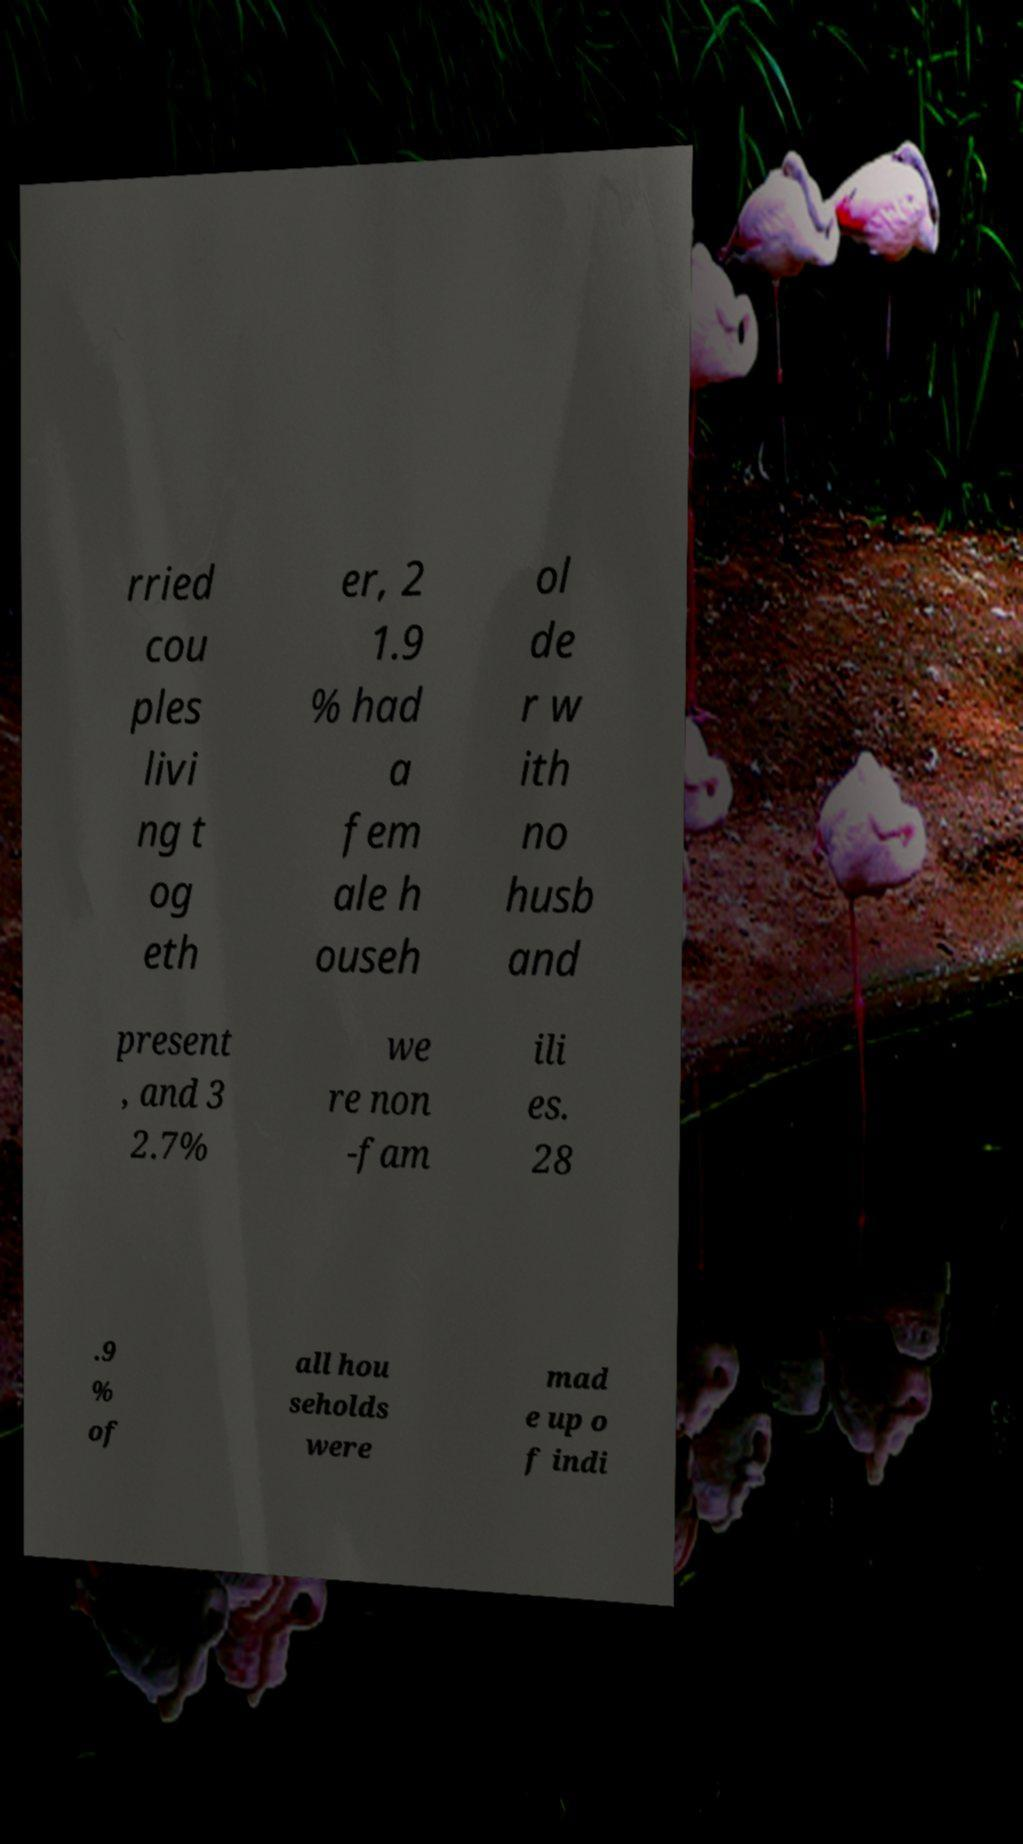There's text embedded in this image that I need extracted. Can you transcribe it verbatim? rried cou ples livi ng t og eth er, 2 1.9 % had a fem ale h ouseh ol de r w ith no husb and present , and 3 2.7% we re non -fam ili es. 28 .9 % of all hou seholds were mad e up o f indi 